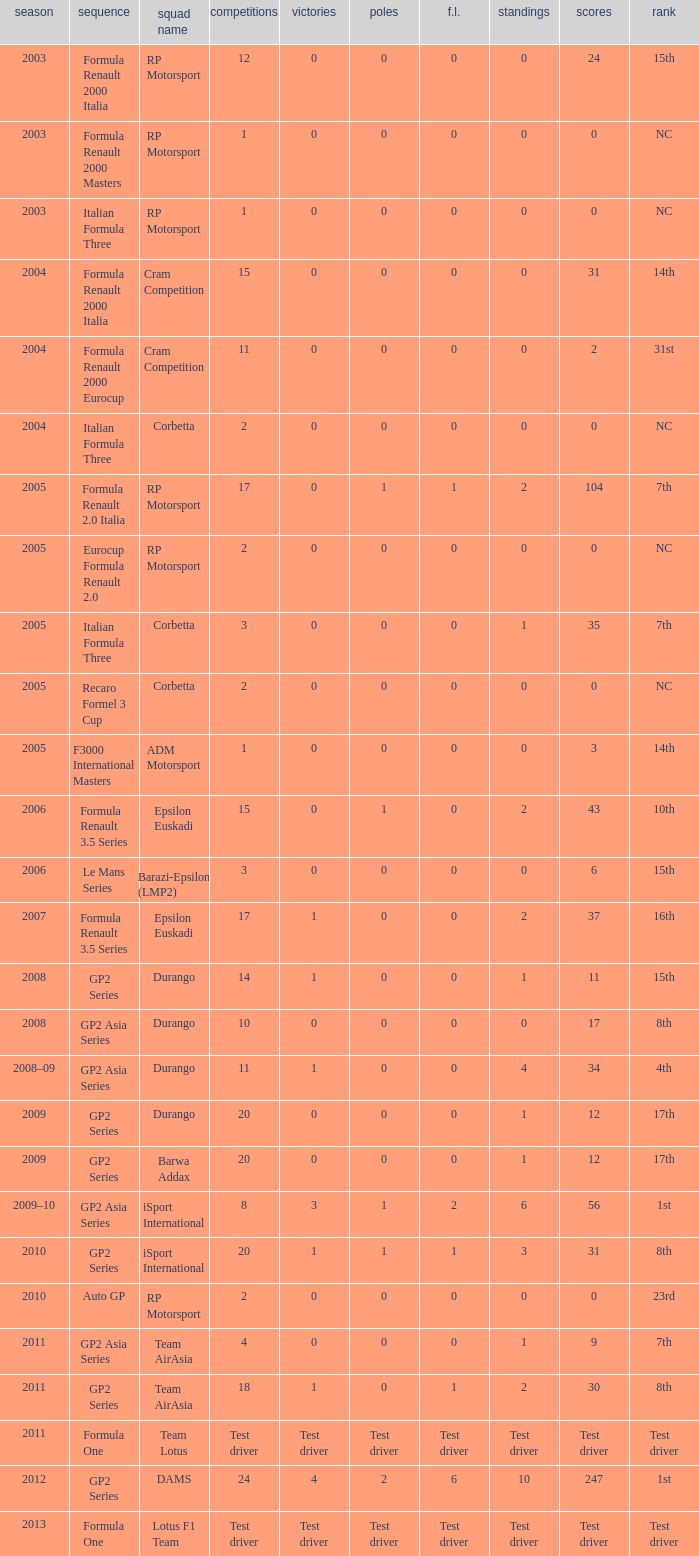What is the number of poles with 4 races? 0.0. 